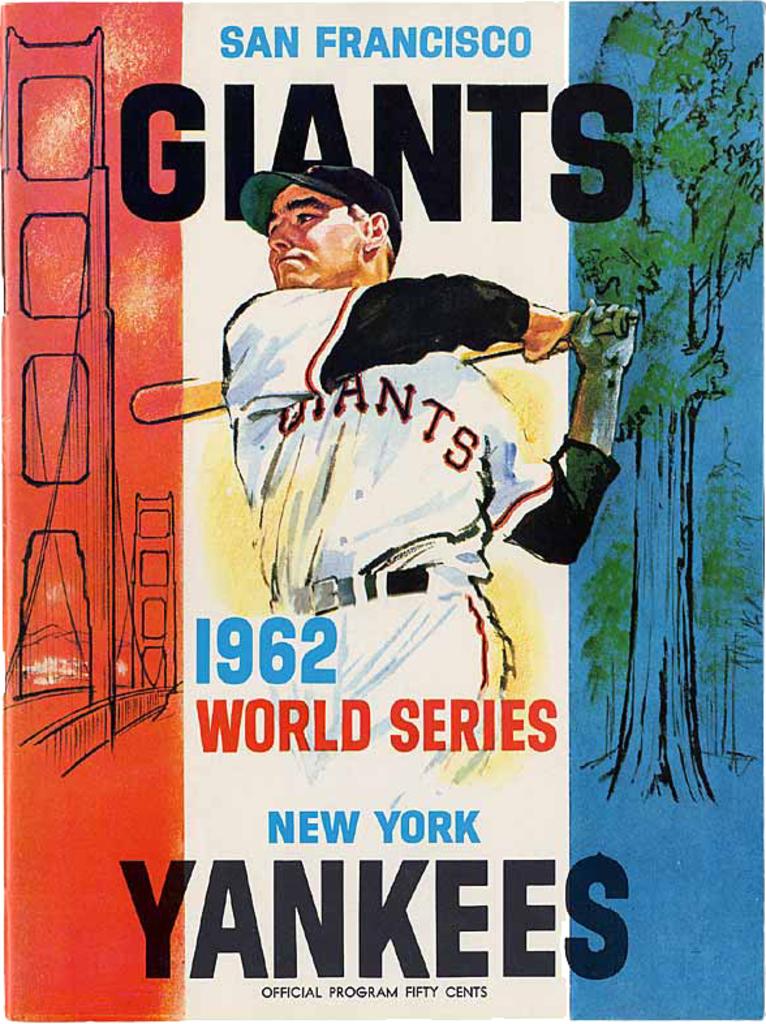What city are the giants from?
Keep it short and to the point. San francisco. 